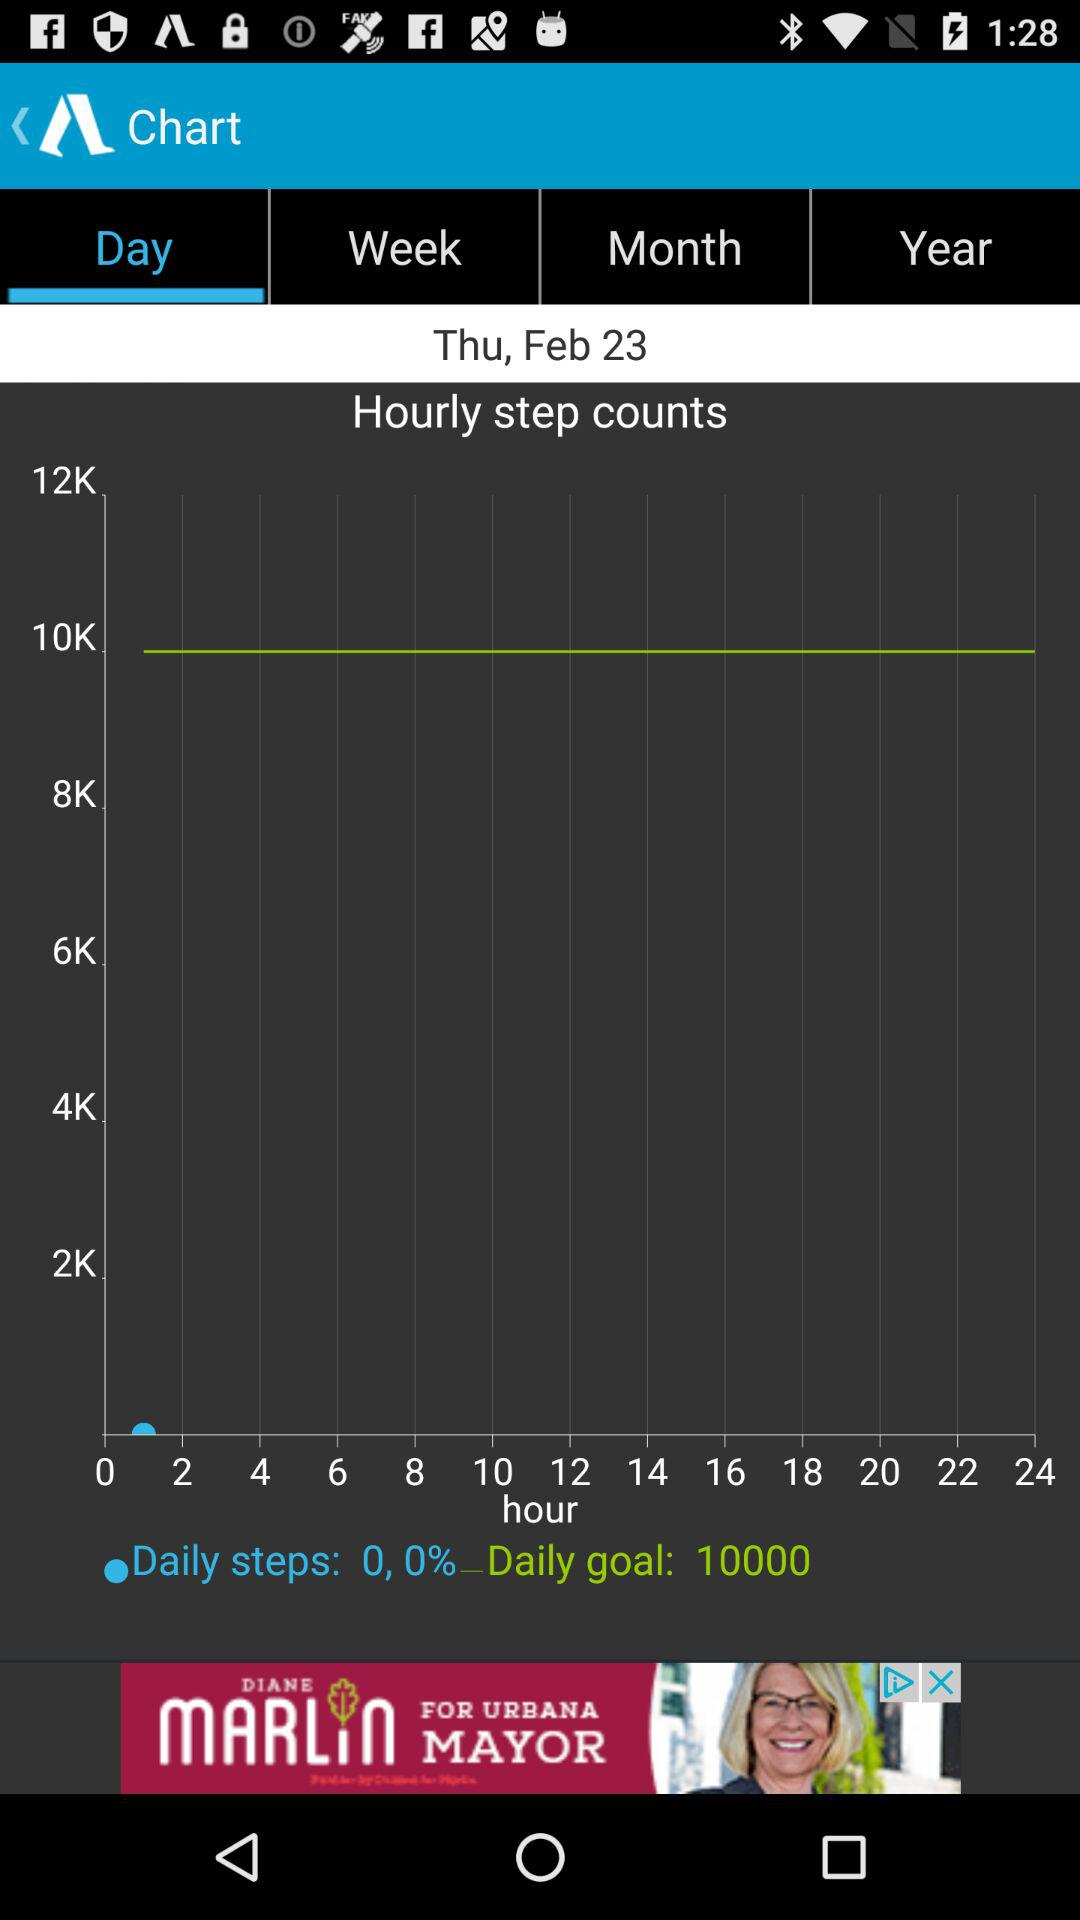Which tab is currently selected? The currently selected tab is "Day". 